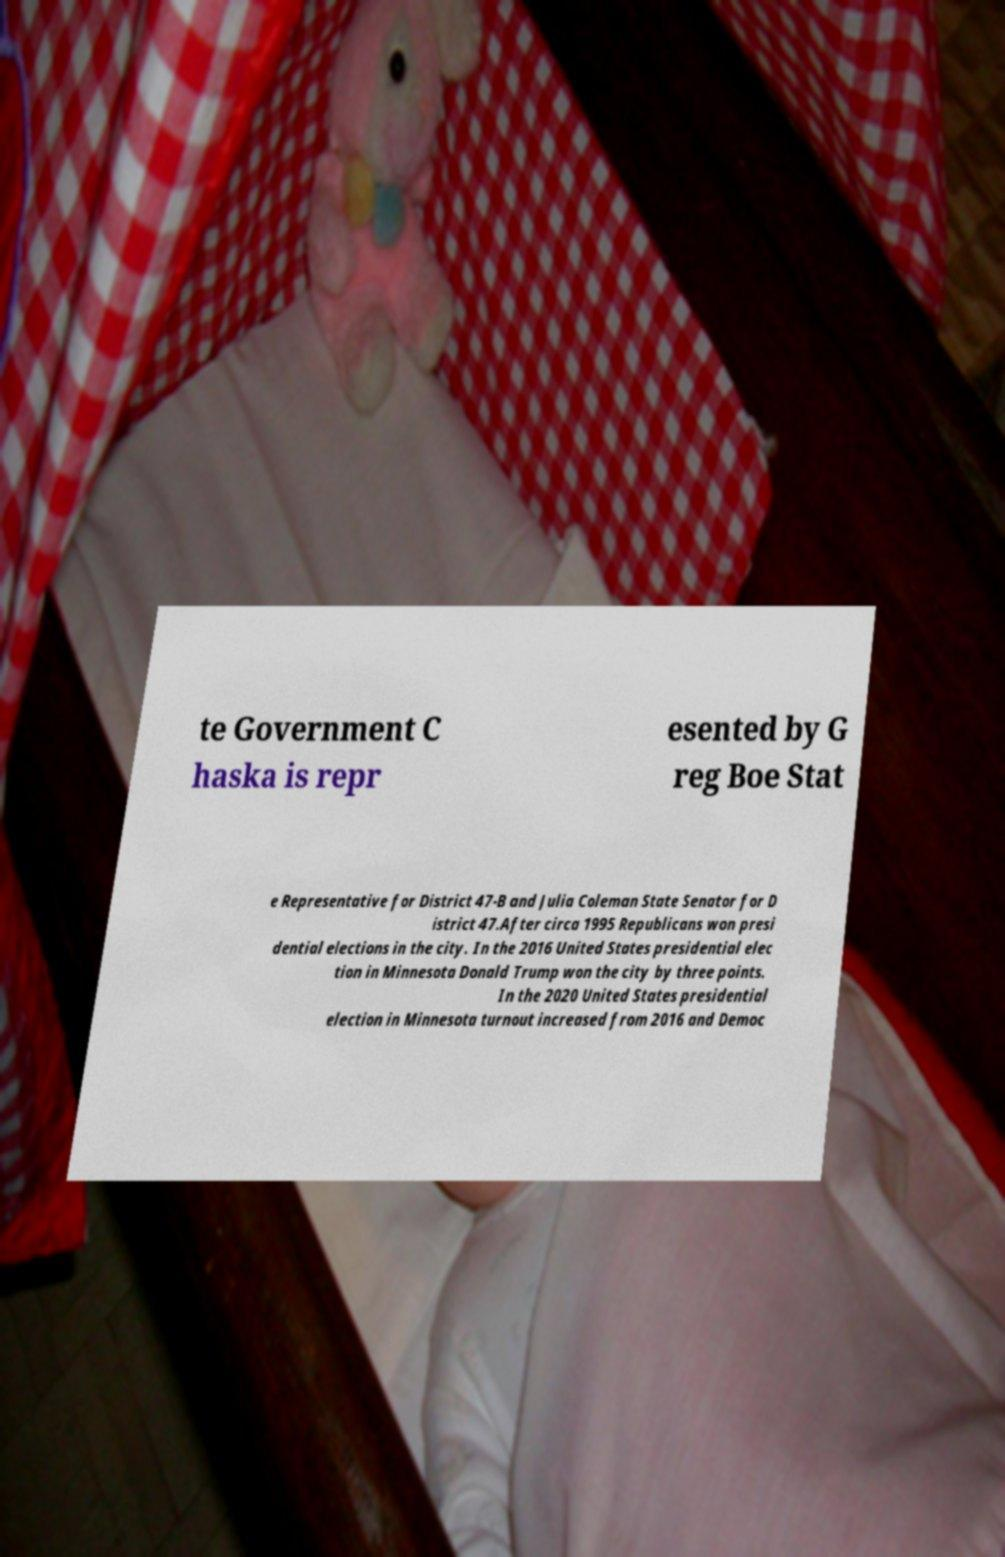For documentation purposes, I need the text within this image transcribed. Could you provide that? te Government C haska is repr esented by G reg Boe Stat e Representative for District 47-B and Julia Coleman State Senator for D istrict 47.After circa 1995 Republicans won presi dential elections in the city. In the 2016 United States presidential elec tion in Minnesota Donald Trump won the city by three points. In the 2020 United States presidential election in Minnesota turnout increased from 2016 and Democ 